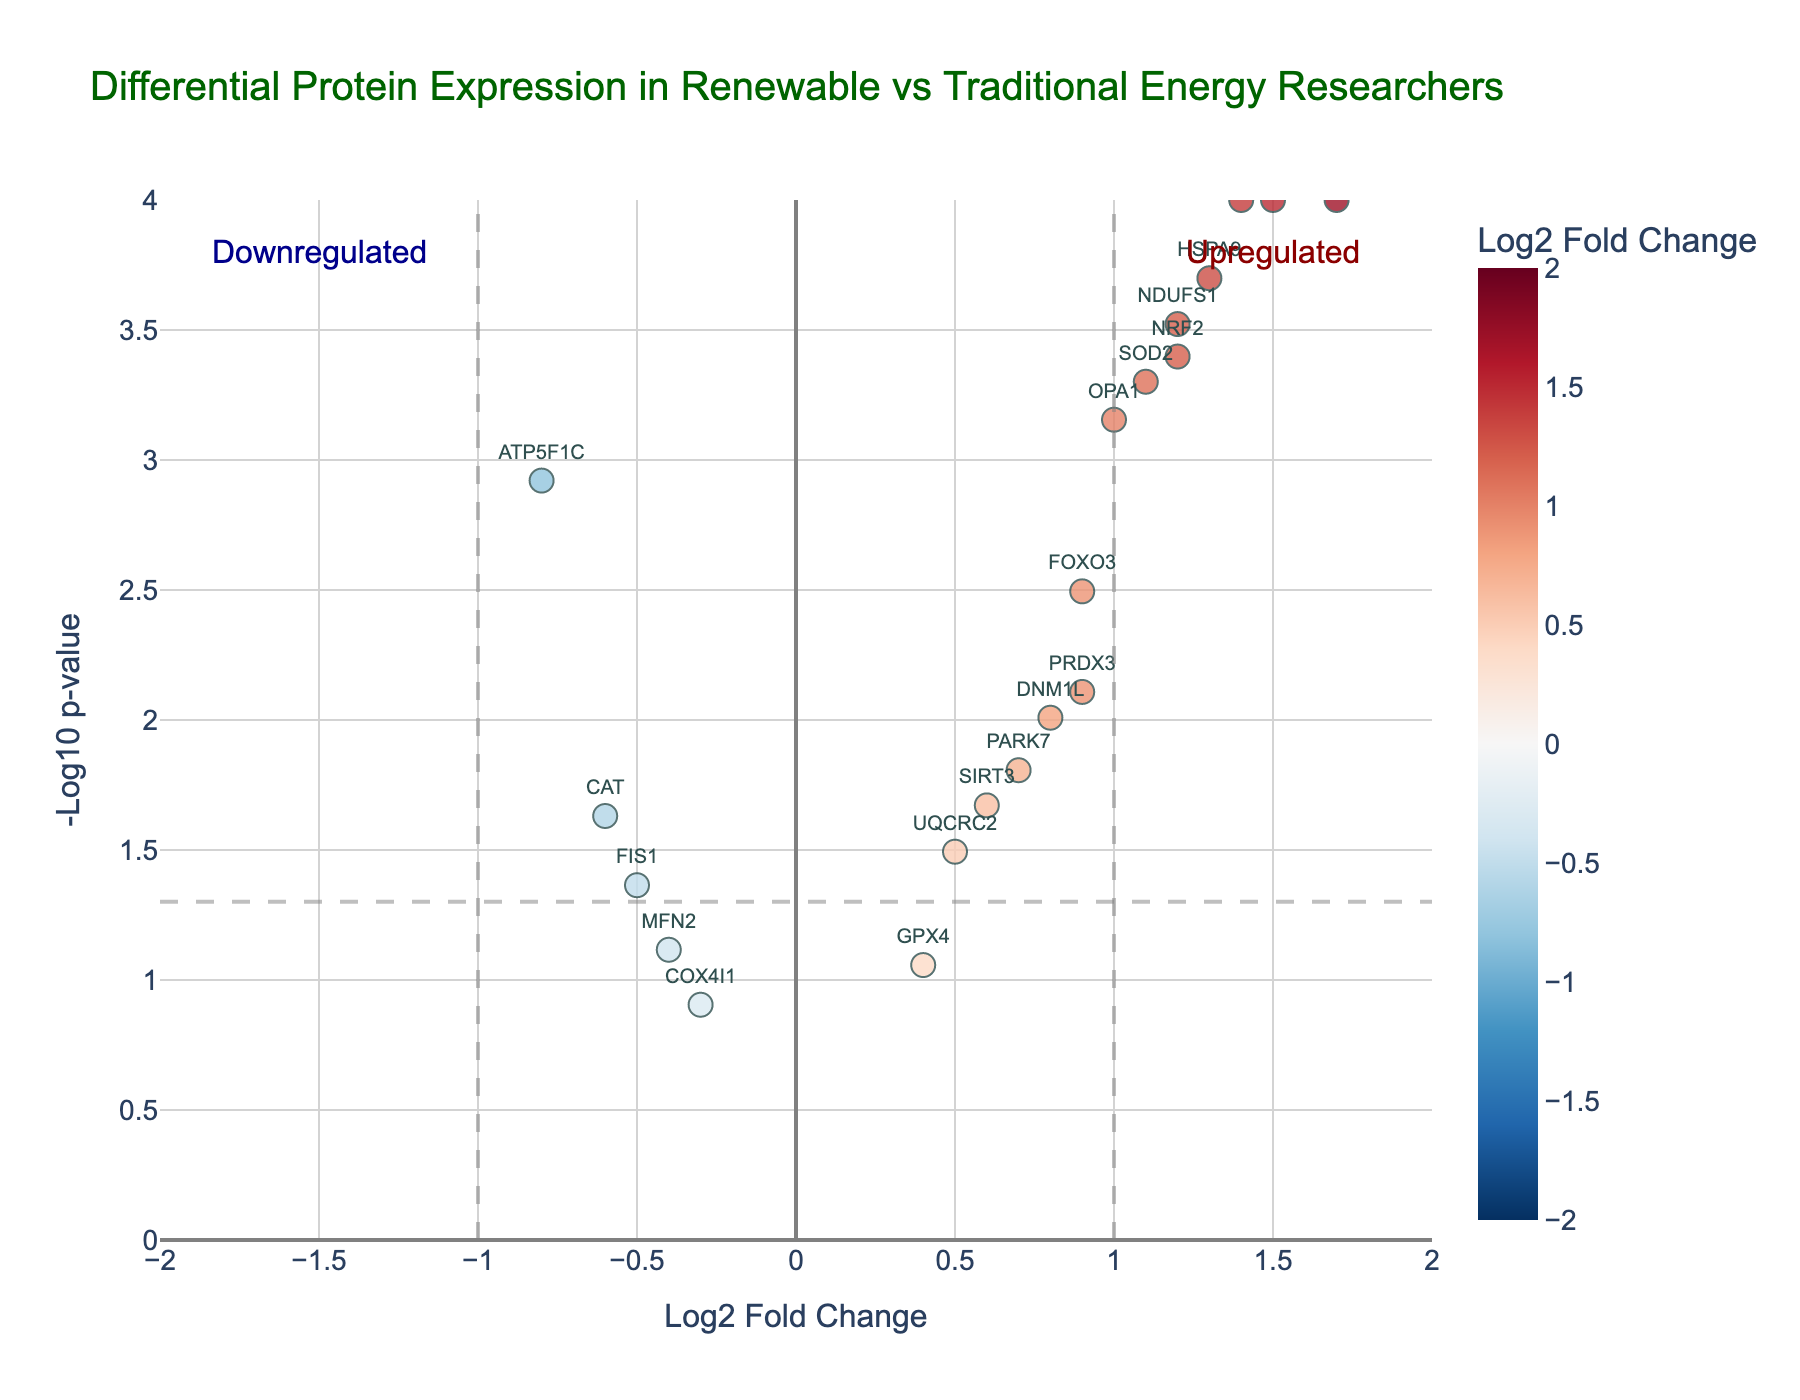What's the title of the plot? The title is displayed at the top center of the plot, indicating it summarizes the data being visualized. It reads "Differential Protein Expression in Renewable vs Traditional Energy Researchers".
Answer: Differential Protein Expression in Renewable vs Traditional Energy Researchers What do the x-axis and y-axis represent? The x-axis represents the log2 fold change, while the y-axis represents the -log10 p-value. These axes help in visualizing the magnitude of change and the statistical significance of proteins respectively.
Answer: Log2 Fold Change and -Log10 p-value How many proteins are significantly upregulated? Proteins are significantly upregulated if they have log2 fold change > 1 and -log10 p-value > -log10(0.05). By inspecting the plot, count the data points that satisfy these conditions. The proteins are: NDUFS1, SDHA, HSPA9, OPA1, TFAM, NRF2, and PGC1A.
Answer: 7 Which protein has the highest log2 fold change? The highest value on the x-axis indicates the highest log2 fold change. By examining the plot, identify the data point farthest to the right. This protein is SDHA with a log2 fold change of 1.7.
Answer: SDHA Which protein has the lowest p-value? The lowest p-value corresponds to the highest -log10 p-value, so we look for the highest point on the y-axis. This protein is TFAM with a -log10 p-value around 4.
Answer: TFAM Are there more upregulated or downregulated proteins? To determine this, compare the number of proteins with log2 fold change > 0 (upregulated) and log2 fold change < 0 (downregulated). By inspection, there are more upregulated proteins as compared to downregulated ones.
Answer: More upregulated proteins What protein is annotated furthest to the bottom of the plot? Proteins are annotated at their respective coordinates on the plot. The one closest to the bottom y-axis will have the highest p-value and less significance. This protein is COX4I1.
Answer: COX4I1 What are the log2 fold change and p-value for protein PARK7? Find the data point labeled "PARK7". The plot tooltip or annotation gives the values: log2FoldChange = 0.7, pvalue = 0.0156.
Answer: 0.7, 0.0156 Which region of the plot indicates proteins with high statistical significance? The region corresponding to high statistical significance is above the threshold line at -log10(p-value) = -log10(0.05). This area will have points above this line.
Answer: Above the threshold line at -log10(p-value) = 1.3 What does the color of the points represent in the plot? The plot uses color to represent the log2 fold change, transitioning from red (higher values) to blue (lower values). This color scheme helps to differentiate the extent of changes.
Answer: Log2 fold change 